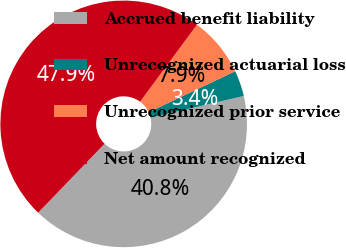<chart> <loc_0><loc_0><loc_500><loc_500><pie_chart><fcel>Accrued benefit liability<fcel>Unrecognized actuarial loss<fcel>Unrecognized prior service<fcel>Net amount recognized<nl><fcel>40.83%<fcel>3.39%<fcel>7.85%<fcel>47.93%<nl></chart> 